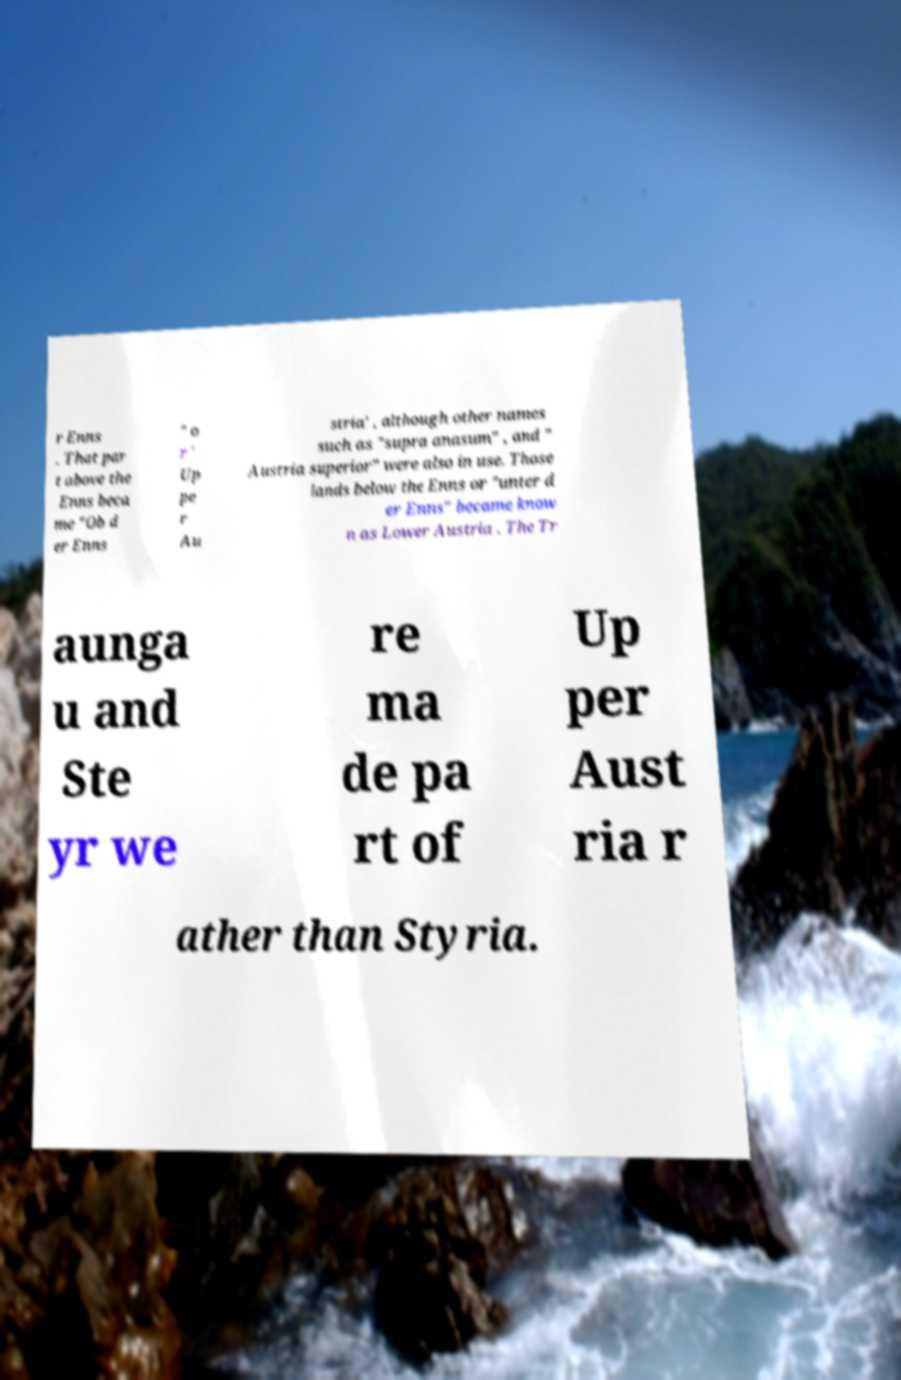Could you assist in decoding the text presented in this image and type it out clearly? r Enns . That par t above the Enns beca me "Ob d er Enns " o r ' Up pe r Au stria' , although other names such as "supra anasum" , and " Austria superior" were also in use. Those lands below the Enns or "unter d er Enns" became know n as Lower Austria . The Tr aunga u and Ste yr we re ma de pa rt of Up per Aust ria r ather than Styria. 